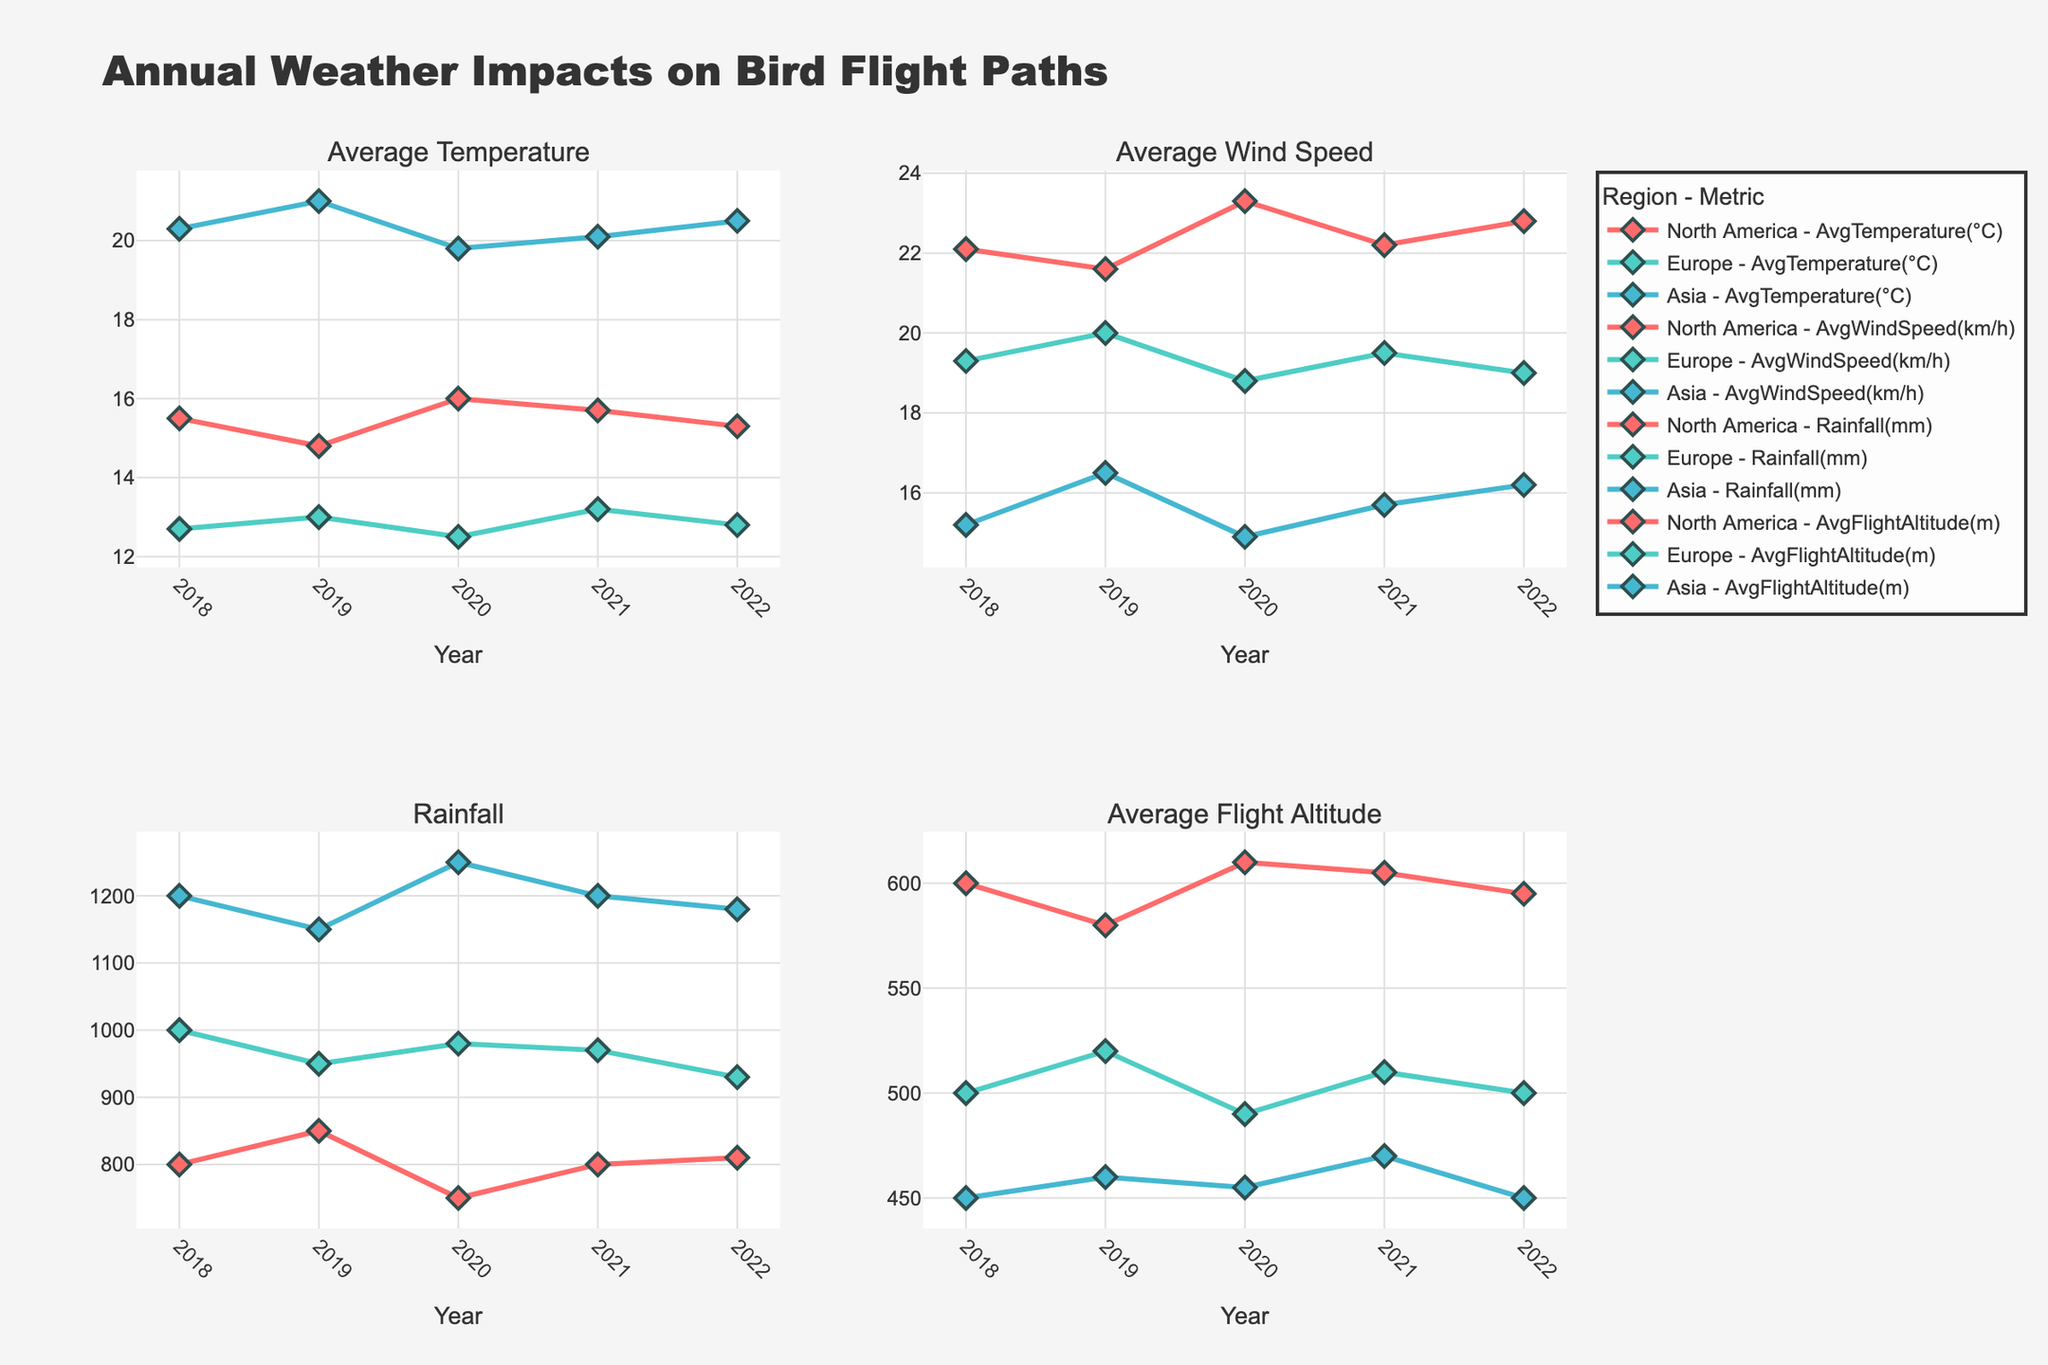What's the trend in average temperature for North America from 2018 to 2022? The average temperature for North America was 15.5°C in 2018, 14.8°C in 2019, 16.0°C in 2020, 15.7°C in 2021, and 15.3°C in 2022. There are slight fluctuations, but no clear upward or downward trend.
Answer: Slight fluctuations Which region had the highest average wind speed in 2020? In 2020, the average wind speed was 23.3 km/h in North America, 18.8 km/h in Europe, and 14.9 km/h in Asia. North America had the highest average wind speed.
Answer: North America Did rainfall in Europe increase or decrease from 2018 to 2022? Rainfall in Europe was 1000 mm in 2018, 950 mm in 2019, 980 mm in 2020, 970 mm in 2021, and 930 mm in 2022. Therefore, it decreased overall from 2018 to 2022.
Answer: Decrease In which year did the Red-Crowned Crane in Asia have the highest average flight altitude? The highest average flight altitude for the Red-Crowned Crane in Asia was 470 meters in 2021.
Answer: 2021 Compare the migration periods for European Swallows and Red-Crowned Cranes. Which species has a longer migration period? The European Swallow's migration period is from April to October (7 months), while the Red-Crowned Crane's migration period is from March to June (4 months). Therefore, the European Swallow has a longer migration period.
Answer: European Swallow What was the average rainfall in Asia over the five years? The rainfall in Asia was 1200 mm in 2018, 1150 mm in 2019, 1250 mm in 2020, 1200 mm in 2021, and 1180 mm in 2022. The average rainfall is (1200 + 1150 + 1250 + 1200 + 1180) / 5 = 1196 mm.
Answer: 1196 mm Which year's average temperature in Europe was closest to the overall average temperature over the five years? The average temperatures in Europe were 12.7°C in 2018, 13.0°C in 2019, 12.5°C in 2020, 13.2°C in 2021, and 12.8°C in 2022. The overall average is (12.7 + 13.0 + 12.5 + 13.2 + 12.8) / 5 = 12.84°C. The year 2022, with 12.8°C, is closest to the overall average.
Answer: 2022 Are the average flight altitudes of the Bald Eagle and the European Swallow increasing or decreasing from 2018 to 2022? For the Bald Eagle: 600m (2018), 580m (2019), 610m (2020), 605m (2021), and 595m (2022). For the European Swallow: 500m (2018), 520m (2019), 490m (2020), 510m (2021), and 500m (2022). The Bald Eagle shows slight fluctuations with no clear trend, while the European Swallow shows slight fluctuations with no clear trend.
Answer: No clear trend Did the average wind speed in North America ever go below 20 km/h between 2018 and 2022? The average wind speeds in North America were 22.1 km/h (2018), 21.6 km/h (2019), 23.3 km/h (2020), 22.2 km/h (2021), and 22.8 km/h (2022). It never went below 20 km/h.
Answer: No Which region had the most significant change in average flight altitude between 2018 and 2022? Comparing the changes over the years: North America (600m to 595m), Europe (500m to 500m), Asia (450m to 450m). North America had the most significant decrease of 5 meters.
Answer: North America 